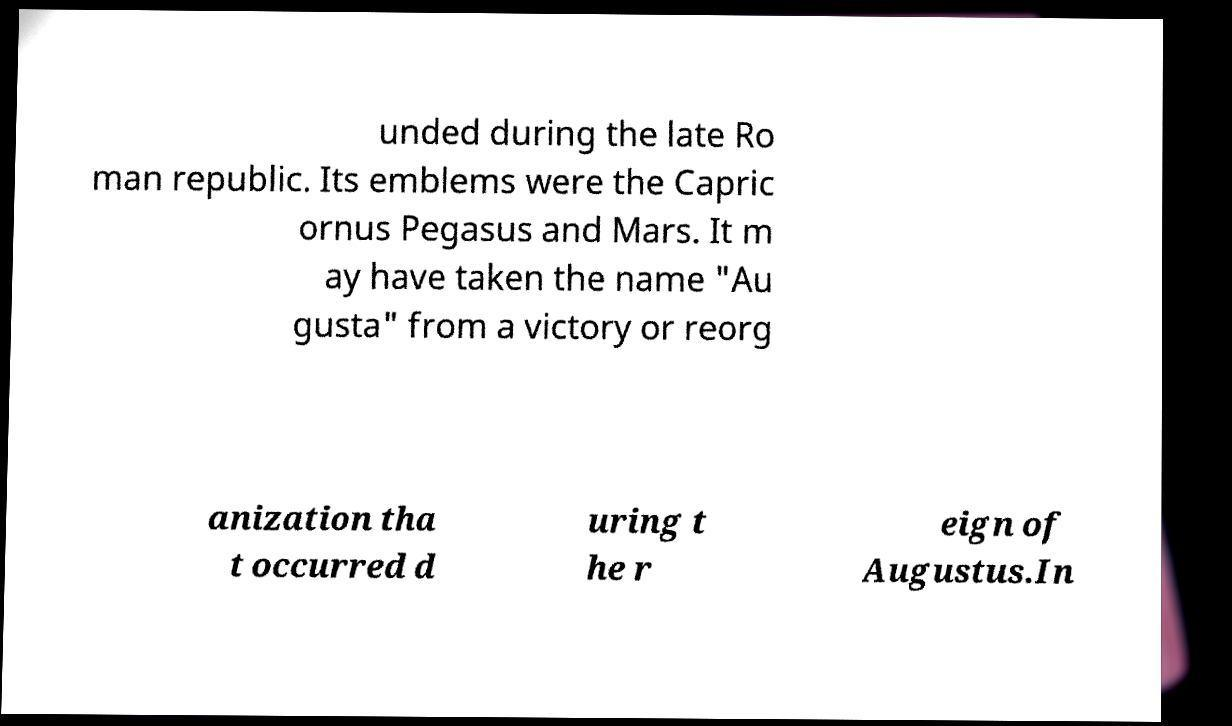Can you accurately transcribe the text from the provided image for me? unded during the late Ro man republic. Its emblems were the Capric ornus Pegasus and Mars. It m ay have taken the name "Au gusta" from a victory or reorg anization tha t occurred d uring t he r eign of Augustus.In 